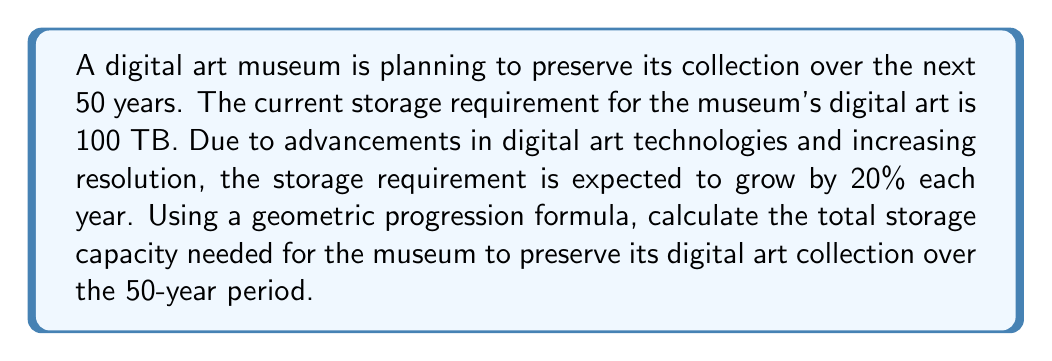Provide a solution to this math problem. To solve this problem, we need to use the formula for the sum of a geometric progression:

$$S_n = a\frac{1-r^n}{1-r}$$

Where:
$S_n$ is the sum of the geometric progression
$a$ is the first term (initial storage requirement)
$r$ is the common ratio (annual growth rate + 1)
$n$ is the number of terms (years)

Given:
$a = 100$ TB (initial storage)
$r = 1.20$ (20% growth rate + 1)
$n = 50$ years

Let's calculate step by step:

1) Substitute the values into the formula:

   $$S_{50} = 100 \cdot \frac{1-1.20^{50}}{1-1.20}$$

2) Calculate $1.20^{50}$:
   
   $1.20^{50} \approx 9064.072$

3) Substitute this value:

   $$S_{50} = 100 \cdot \frac{1-9064.072}{1-1.20}$$

4) Simplify:

   $$S_{50} = 100 \cdot \frac{-9063.072}{-0.20}$$

5) Calculate the final result:

   $$S_{50} = 100 \cdot 45315.36 = 4,531,536$$ TB

Therefore, the total storage capacity needed over the 50-year period is approximately 4,531,536 TB or 4.53 PB (petabytes).
Answer: 4,531,536 TB or 4.53 PB 